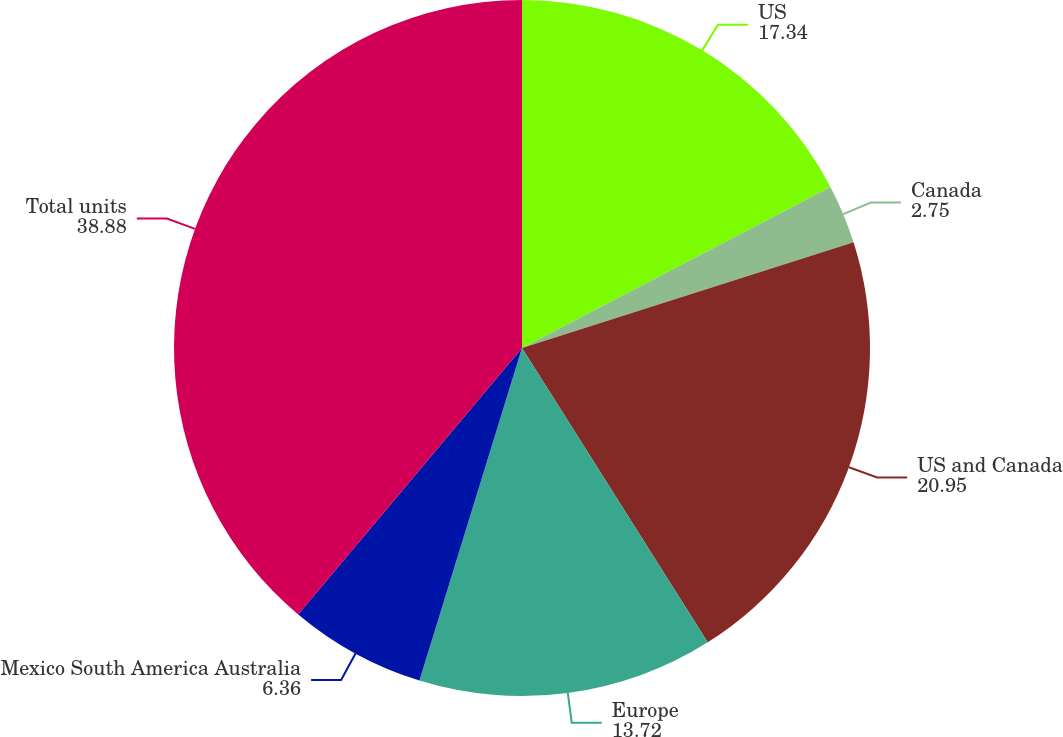<chart> <loc_0><loc_0><loc_500><loc_500><pie_chart><fcel>US<fcel>Canada<fcel>US and Canada<fcel>Europe<fcel>Mexico South America Australia<fcel>Total units<nl><fcel>17.34%<fcel>2.75%<fcel>20.95%<fcel>13.72%<fcel>6.36%<fcel>38.88%<nl></chart> 